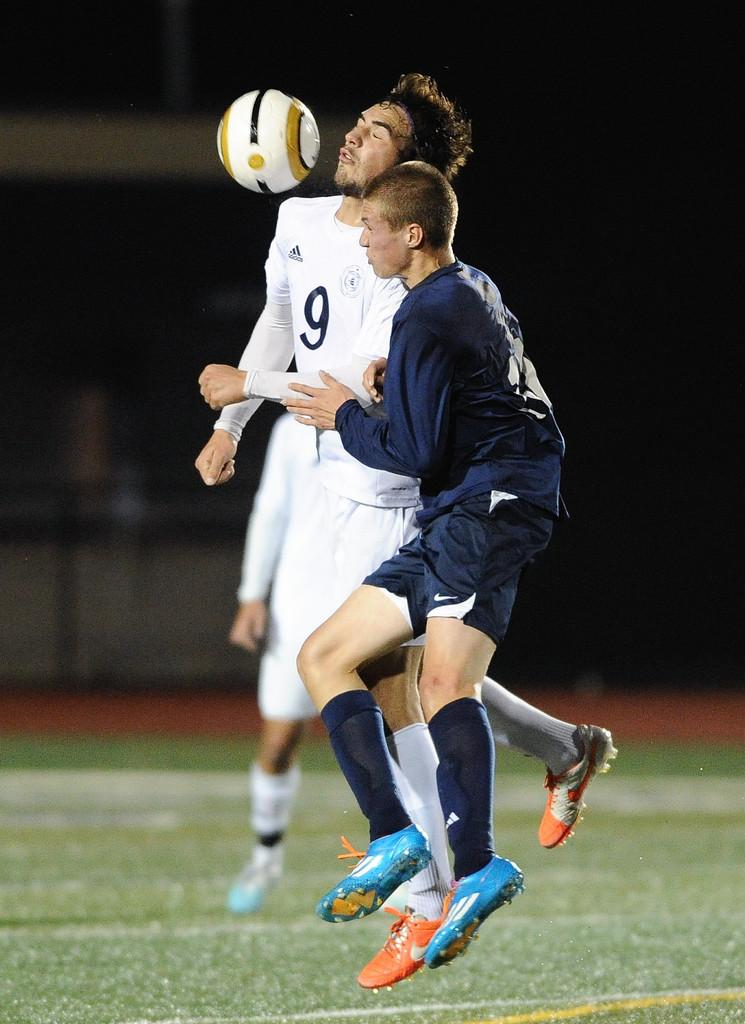<image>
Describe the image concisely. two foot ball players try to take the food ball and one of them has  jersey number  9 